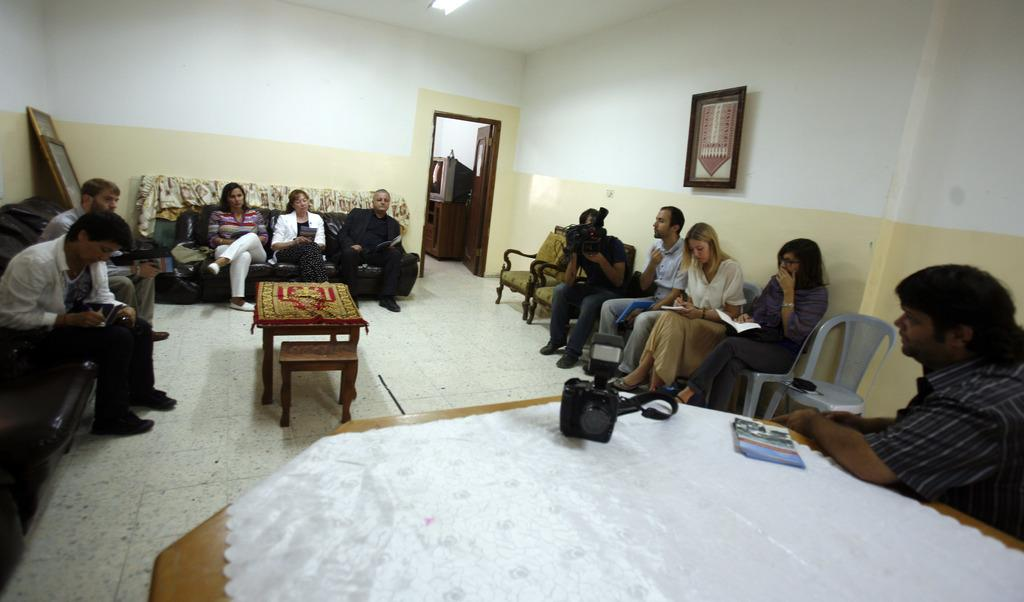How many people are in the image? There is a group of people in the image. What are the people doing in the image? The people are sitting on a couch. Can you describe the background of the image? There is a wall and a frame in the background. What is the man in the background holding? The man in the background is holding a camera. How many threads are visible in the image? There is no mention of threads in the image, so it is not possible to determine how many are visible. 